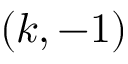<formula> <loc_0><loc_0><loc_500><loc_500>( k , - 1 )</formula> 